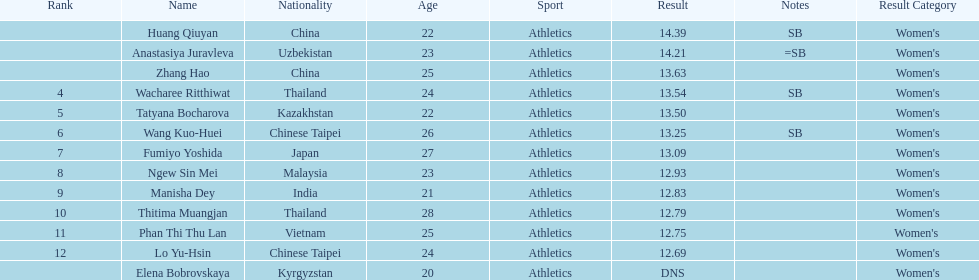What was the average result of the top three jumpers? 14.08. 